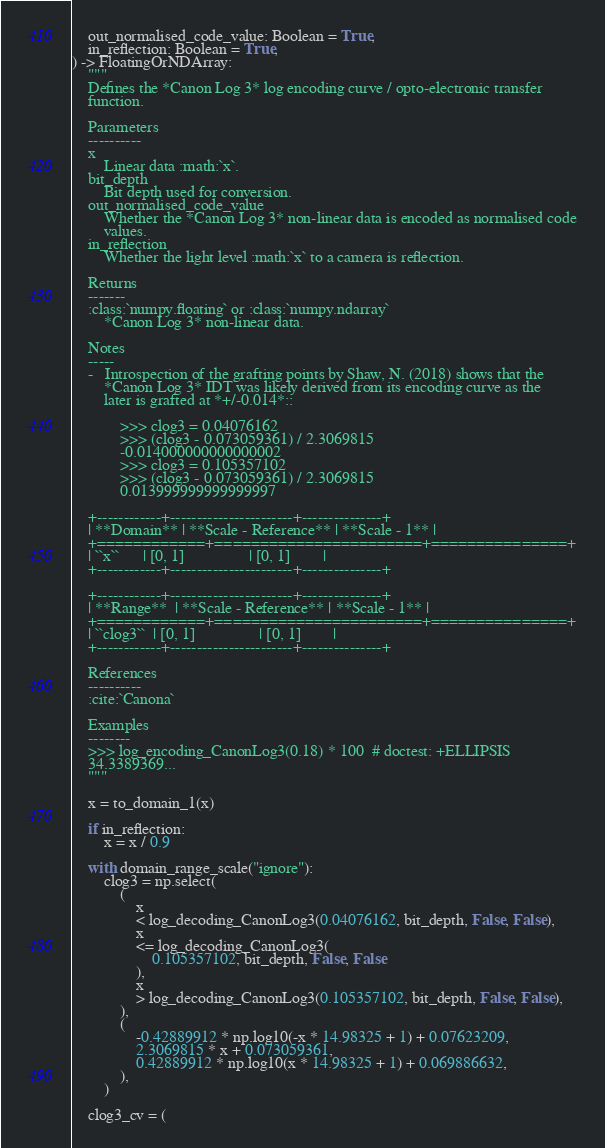Convert code to text. <code><loc_0><loc_0><loc_500><loc_500><_Python_>    out_normalised_code_value: Boolean = True,
    in_reflection: Boolean = True,
) -> FloatingOrNDArray:
    """
    Defines the *Canon Log 3* log encoding curve / opto-electronic transfer
    function.

    Parameters
    ----------
    x
        Linear data :math:`x`.
    bit_depth
        Bit depth used for conversion.
    out_normalised_code_value
        Whether the *Canon Log 3* non-linear data is encoded as normalised code
        values.
    in_reflection
        Whether the light level :math:`x` to a camera is reflection.

    Returns
    -------
    :class:`numpy.floating` or :class:`numpy.ndarray`
        *Canon Log 3* non-linear data.

    Notes
    -----
    -   Introspection of the grafting points by Shaw, N. (2018) shows that the
        *Canon Log 3* IDT was likely derived from its encoding curve as the
        later is grafted at *+/-0.014*::

            >>> clog3 = 0.04076162
            >>> (clog3 - 0.073059361) / 2.3069815
            -0.014000000000000002
            >>> clog3 = 0.105357102
            >>> (clog3 - 0.073059361) / 2.3069815
            0.013999999999999997

    +------------+-----------------------+---------------+
    | **Domain** | **Scale - Reference** | **Scale - 1** |
    +============+=======================+===============+
    | ``x``      | [0, 1]                | [0, 1]        |
    +------------+-----------------------+---------------+

    +------------+-----------------------+---------------+
    | **Range**  | **Scale - Reference** | **Scale - 1** |
    +============+=======================+===============+
    | ``clog3``  | [0, 1]                | [0, 1]        |
    +------------+-----------------------+---------------+

    References
    ----------
    :cite:`Canona`

    Examples
    --------
    >>> log_encoding_CanonLog3(0.18) * 100  # doctest: +ELLIPSIS
    34.3389369...
    """

    x = to_domain_1(x)

    if in_reflection:
        x = x / 0.9

    with domain_range_scale("ignore"):
        clog3 = np.select(
            (
                x
                < log_decoding_CanonLog3(0.04076162, bit_depth, False, False),
                x
                <= log_decoding_CanonLog3(
                    0.105357102, bit_depth, False, False
                ),
                x
                > log_decoding_CanonLog3(0.105357102, bit_depth, False, False),
            ),
            (
                -0.42889912 * np.log10(-x * 14.98325 + 1) + 0.07623209,
                2.3069815 * x + 0.073059361,
                0.42889912 * np.log10(x * 14.98325 + 1) + 0.069886632,
            ),
        )

    clog3_cv = (</code> 